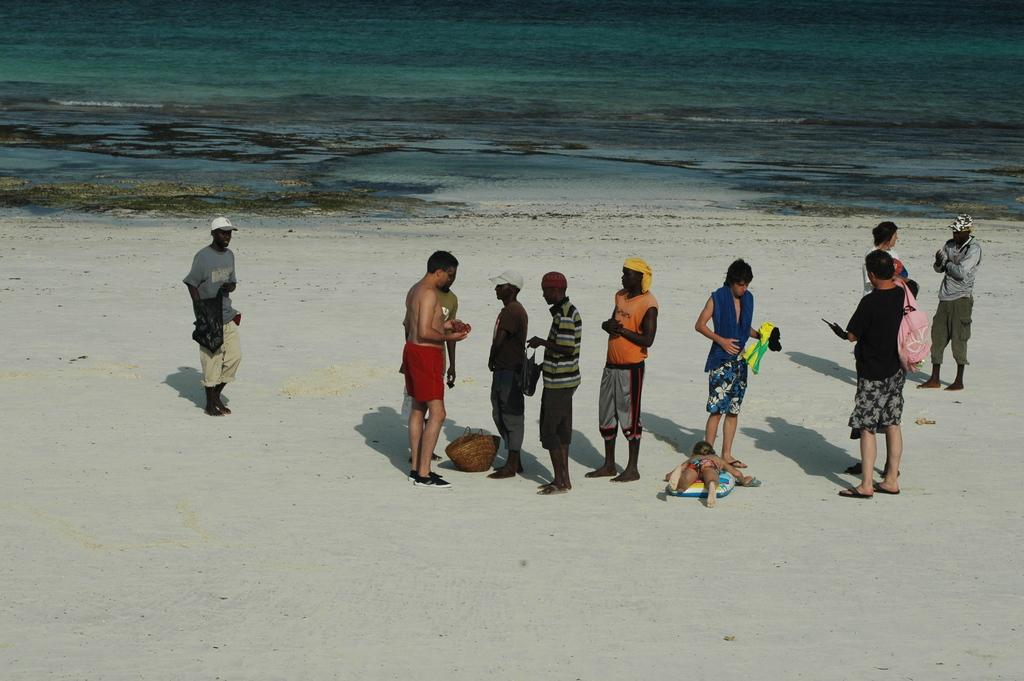Where was the image taken? The image was taken at the beach. What can be seen in the center of the image? There are people standing in the center of the image. What is the kid doing in the image? The kid is lying on the sand in the image. What is visible in the background of the image? There is a sea visible in the background of the image. Can you see a nest in the image? There is no nest visible in the image. What color is the silk in the image? There is no silk present in the image. 